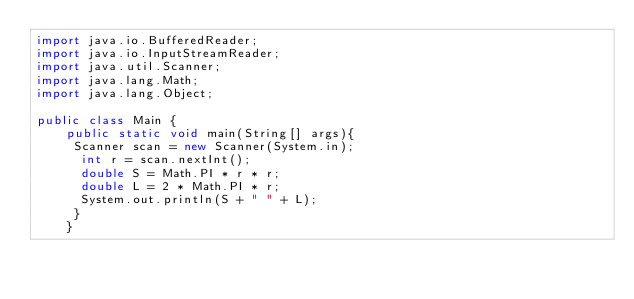<code> <loc_0><loc_0><loc_500><loc_500><_Java_>import java.io.BufferedReader;
import java.io.InputStreamReader;
import java.util.Scanner;
import java.lang.Math;
import java.lang.Object;

public class Main {
    public static void main(String[] args){
     Scanner scan = new Scanner(System.in);
      int r = scan.nextInt();
      double S = Math.PI * r * r;
      double L = 2 * Math.PI * r;
      System.out.println(S + " " + L);
     }
    }
</code> 